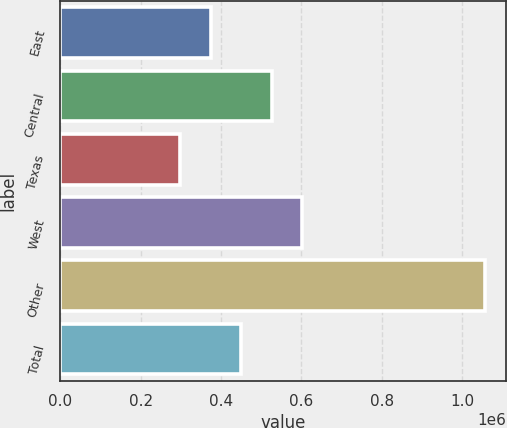<chart> <loc_0><loc_0><loc_500><loc_500><bar_chart><fcel>East<fcel>Central<fcel>Texas<fcel>West<fcel>Other<fcel>Total<nl><fcel>373800<fcel>525400<fcel>298000<fcel>601200<fcel>1.056e+06<fcel>449600<nl></chart> 